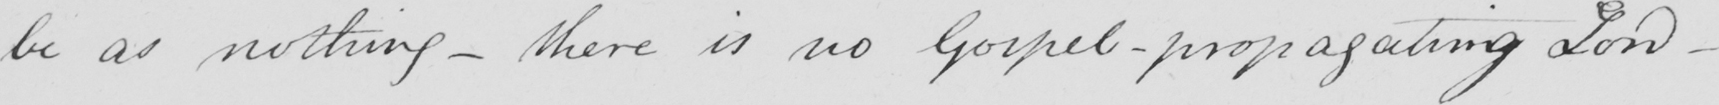Please provide the text content of this handwritten line. be as nothing - there is no Gospel - propagating Lord- 